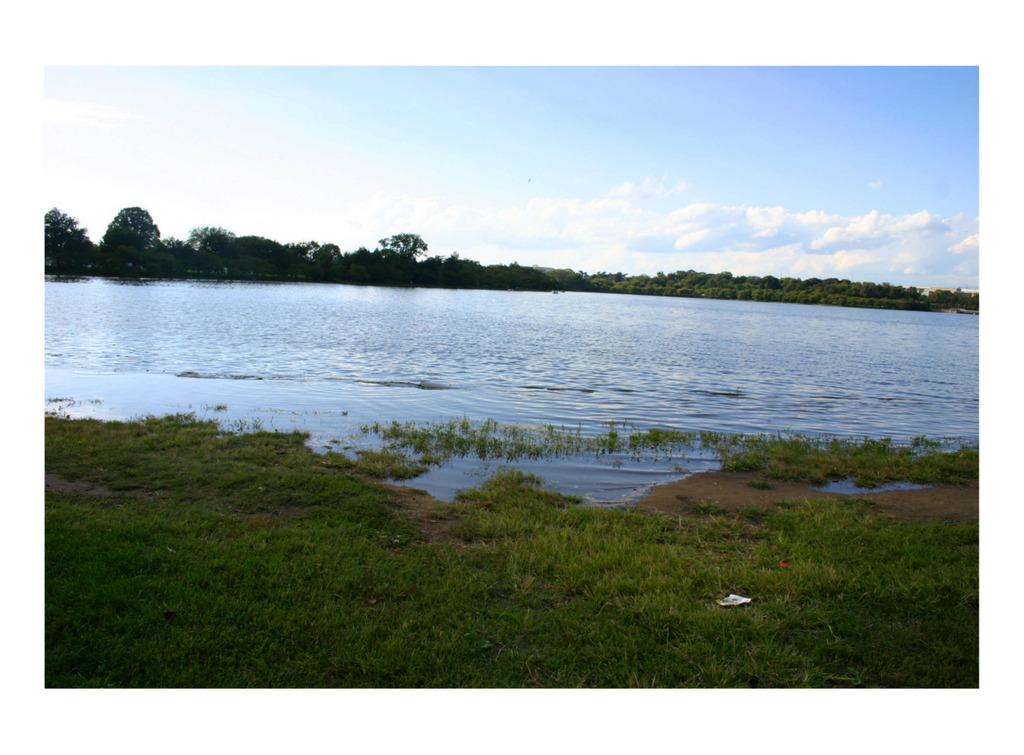What type of vegetation can be seen in the image? There are trees in the image. What natural element is also visible in the image? There is water visible in the image. What is the color of the grass in the image? The grass in the image is green. What is visible at the top of the image? The sky is visible in the image. What colors can be seen in the sky in the image? The sky has white and blue colors. Can you see any elbows in the image? There are no elbows present in the image. Is there any blood visible in the image? There is no blood visible in the image. Is there a trampoline in the image? There is no trampoline present in the image. 